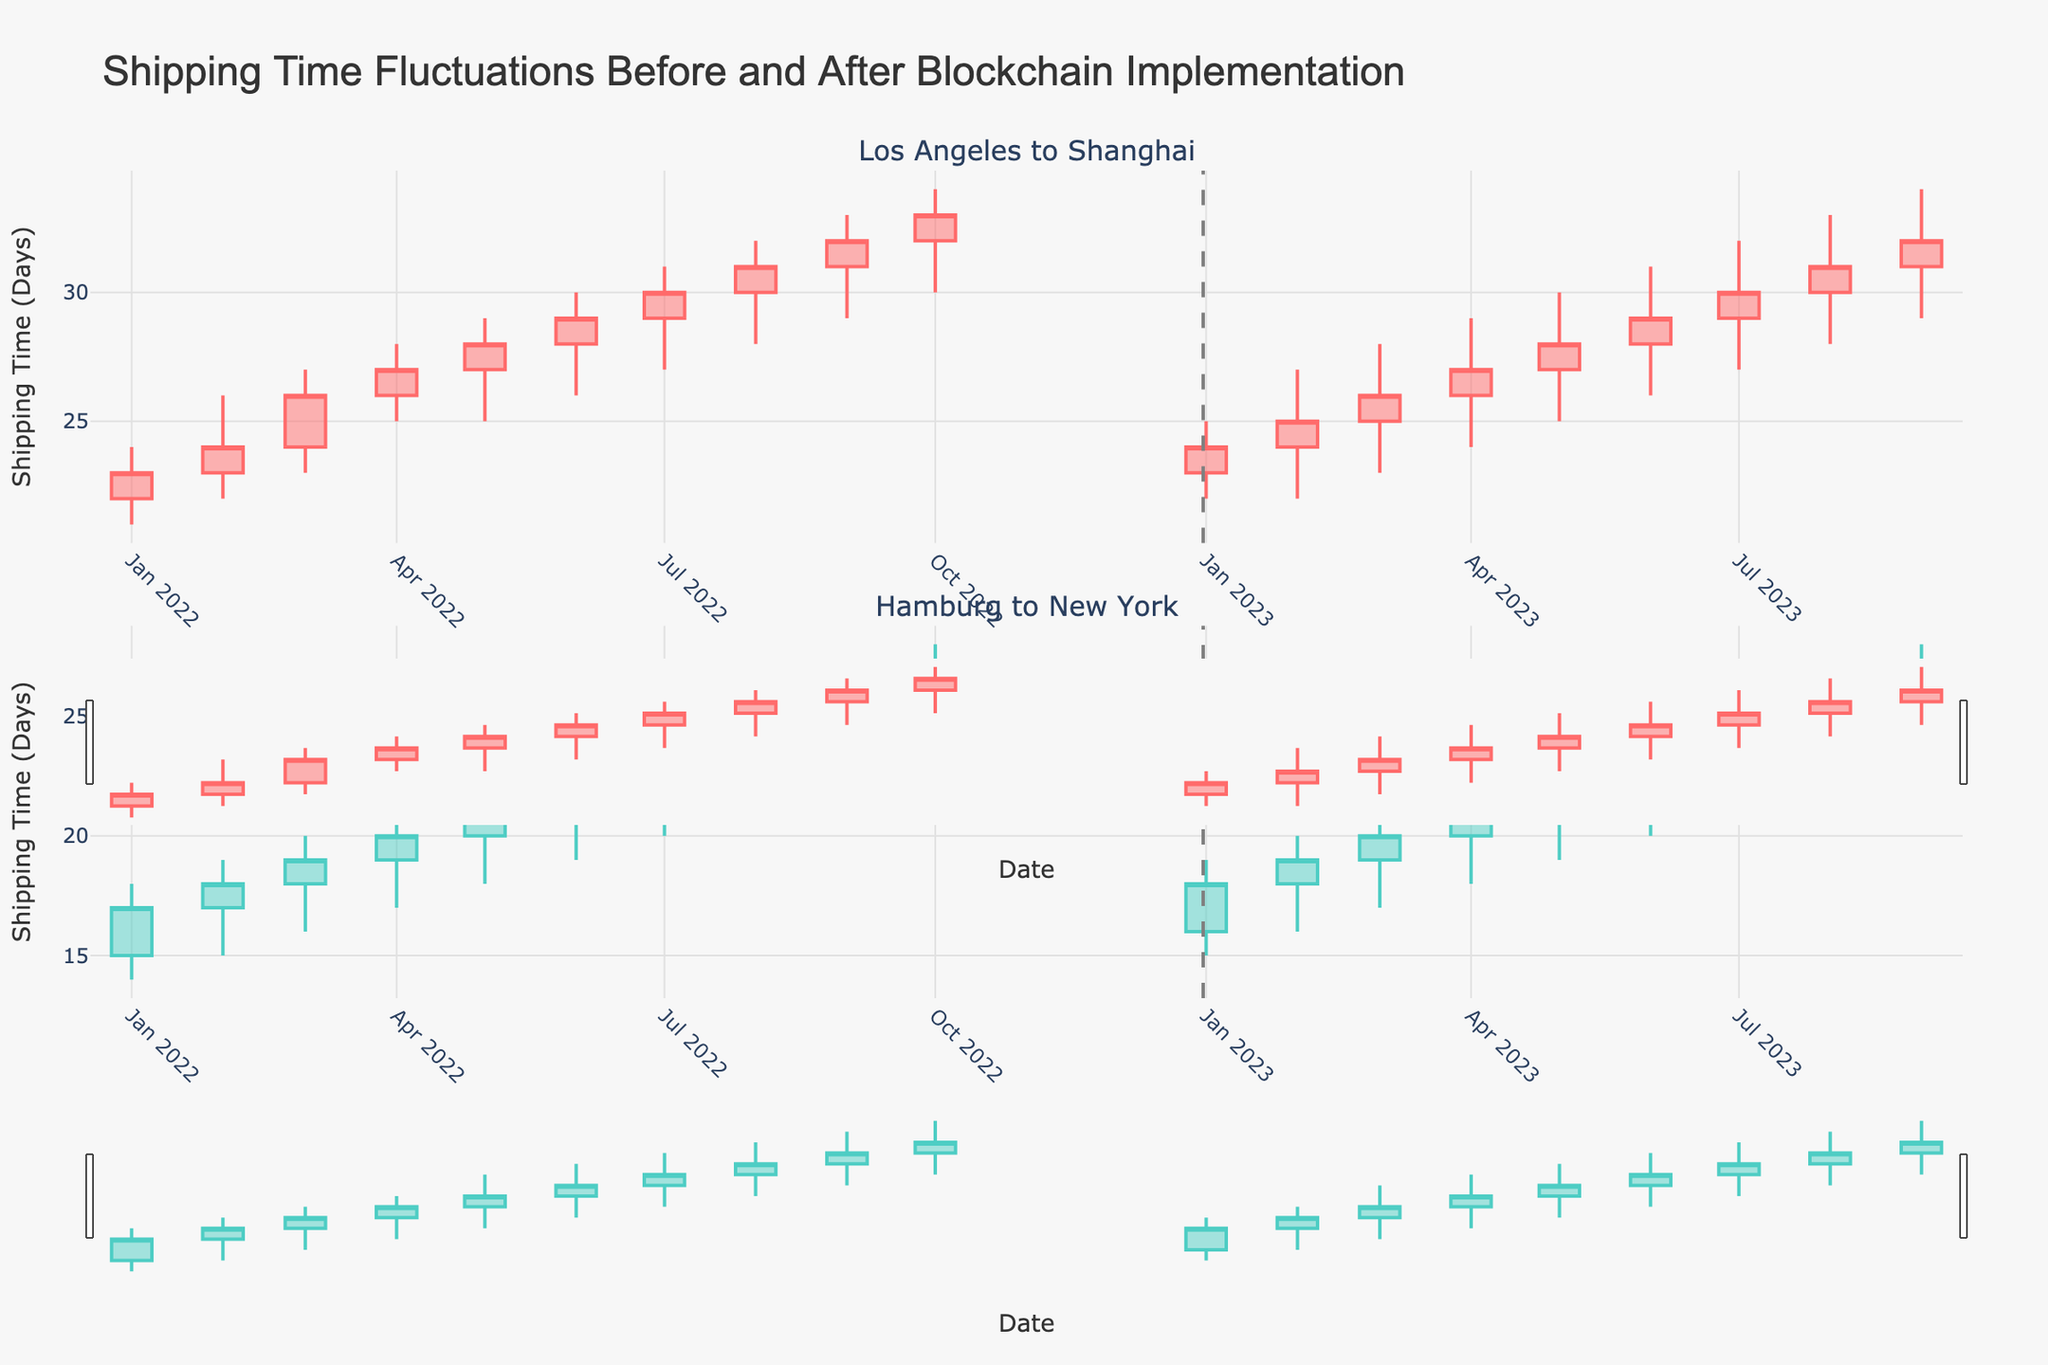What is the title of the plot? The title of the plot is clearly written at the top of the figure: "Shipping Time Fluctuations Before and After Blockchain Implementation".
Answer: Shipping Time Fluctuations Before and After Blockchain Implementation What does the dashed vertical line represent? The dashed vertical line in each subplot represents the date, December 31, 2022, which separates the period before and after blockchain implementation.
Answer: Blockchain implementation date How does the shipping time range for the Los Angeles to Shanghai route in October 2022 compare to October 2023? In October 2022, the shipping time range (low to high) was from 30 to 34 days. In October 2023, the range was similar, from 30 to 34 days.
Answer: Similar Which route shows a greater increase in closing shipping times from January 2022 to January 2023? For the Los Angeles to Shanghai route, the closing time increased from 23 days (January 2022) to 24 days (January 2023). For the Hamburg to New York route, the closing time increased from 17 days (January 2022) to 18 days (January 2023). The increase is greater for the Los Angeles to Shanghai route by 1 day compared to 1 day for the Hamburg to New York route.
Answer: Los Angeles to Shanghai What color are the candlesticks for increments and decrements in the Los Angeles to Shanghai route? The candlesticks for both increments and decrements in the Los Angeles to Shanghai route are represented in the same color, which includes a shade of blue-green.
Answer: Blue-green What is the maximum shipping time for the Hamburg to New York route in September 2023? The maximum shipping time for the Hamburg to New York route in September 2023 can be seen from the highest point on the candlestick, which is 28 days.
Answer: 28 days Which route shows more variability in shipping times, Los Angeles to Shanghai or Hamburg to New York, during 2022? By examining the height of the candlesticks for 2022, it is noticeable that Los Angeles to Shanghai shows more variability because the candlesticks are taller, indicating a wider range between high and low shipping times.
Answer: Los Angeles to Shanghai After blockchain implementation, which route had a smaller range (difference between high and low) in shipping times in April 2023? Analyzing the candlestick for April 2023, Los Angeles to Shanghai had a range of 5 days (29-24), while Hamburg to New York had a range of 5 days (23-18). Both routes show an equal range of 5 days.
Answer: Equal range By how many days did the closing shipping time decrease from December 2022 to January 2023 for the Los Angeles to Shanghai route? The closing shipping time for Los Angeles to Shanghai decreased from 33 days in December 2022 to 24 days in January 2023, resulting in a decrease of 9 days.
Answer: 9 days 